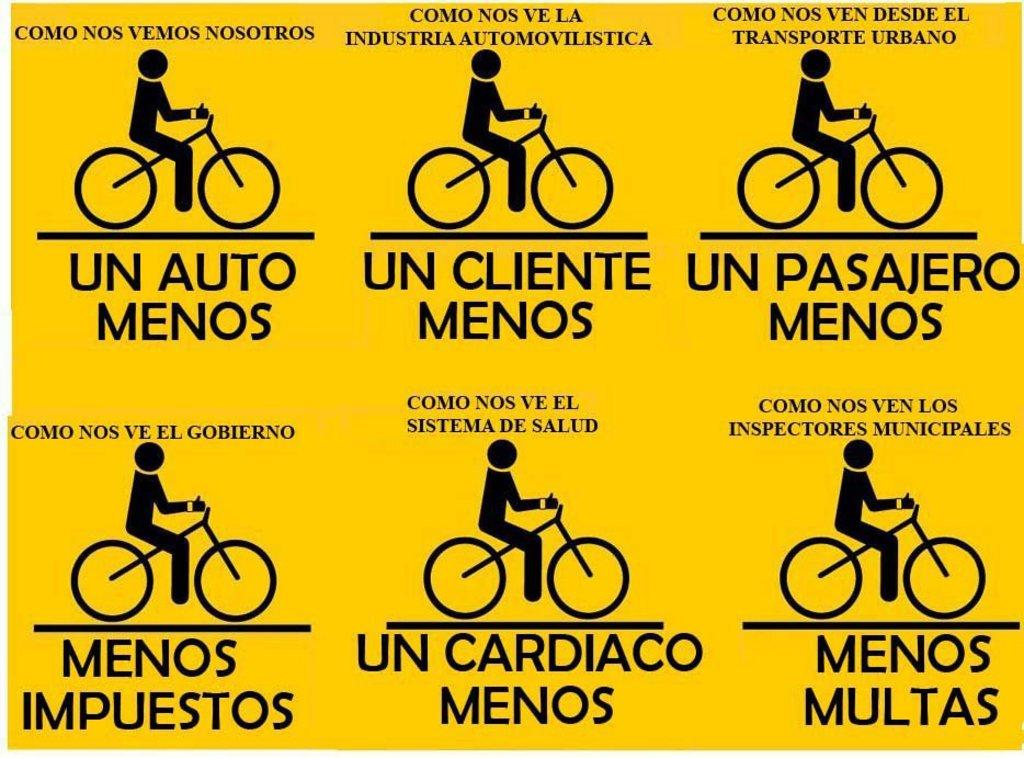What color is the poster in the image? The poster is yellow in color. What is featured on the poster besides its color? There are signs and letters on the poster. Can you tell me how the hen is contributing to the acoustics of the room in the image? There is no hen present in the image, and therefore no such contribution can be observed. What type of burn can be seen on the poster in the image? There is no burn present on the poster in the image. 